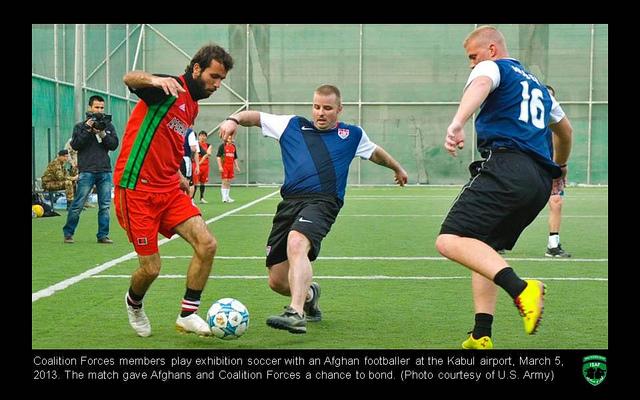How many people are shown?
Answer briefly. 8. How many blue shirts are there?
Give a very brief answer. 2. What sport are they playing?
Answer briefly. Soccer. Do any of the players have beards?
Be succinct. Yes. What sport is this?
Quick response, please. Soccer. What sport is being played?
Quick response, please. Soccer. 